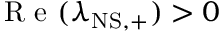<formula> <loc_0><loc_0><loc_500><loc_500>R e ( \lambda _ { N S , + } ) > 0</formula> 